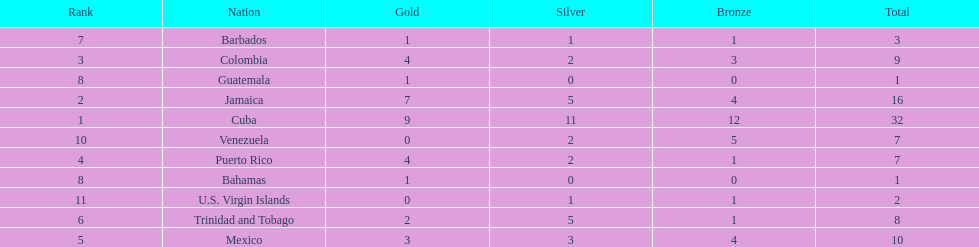What is the difference in medals between cuba and mexico? 22. 